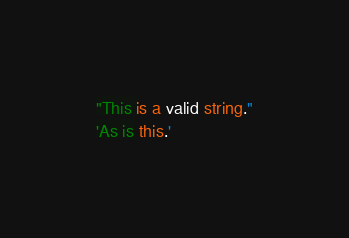Convert code to text. <code><loc_0><loc_0><loc_500><loc_500><_COBOL_>"This is a valid string."
'As is this.'
</code> 